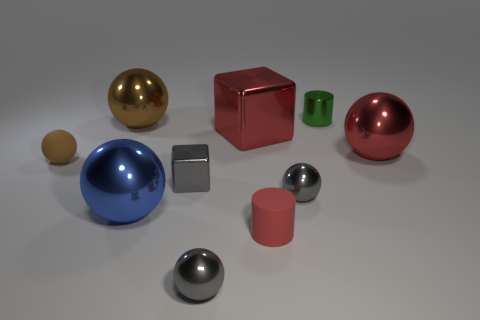Are there any tiny gray cubes left of the brown sphere behind the red metallic object to the right of the big block?
Your answer should be very brief. No. The cylinder behind the red thing that is on the right side of the small red cylinder is made of what material?
Provide a succinct answer. Metal. The red object that is behind the big blue metal ball and to the right of the big red block is made of what material?
Provide a succinct answer. Metal. Are there any large brown shiny things of the same shape as the small brown rubber thing?
Your response must be concise. Yes. Is there a large brown metal ball to the right of the metallic block that is right of the gray block?
Your answer should be very brief. No. What number of other large balls have the same material as the red sphere?
Ensure brevity in your answer.  2. Are there any large blue shiny things?
Your response must be concise. Yes. How many small matte balls are the same color as the matte cylinder?
Your answer should be very brief. 0. Are the large red block and the small sphere behind the tiny gray block made of the same material?
Provide a short and direct response. No. Are there more brown matte balls that are in front of the tiny red thing than small gray metal things?
Ensure brevity in your answer.  No. 